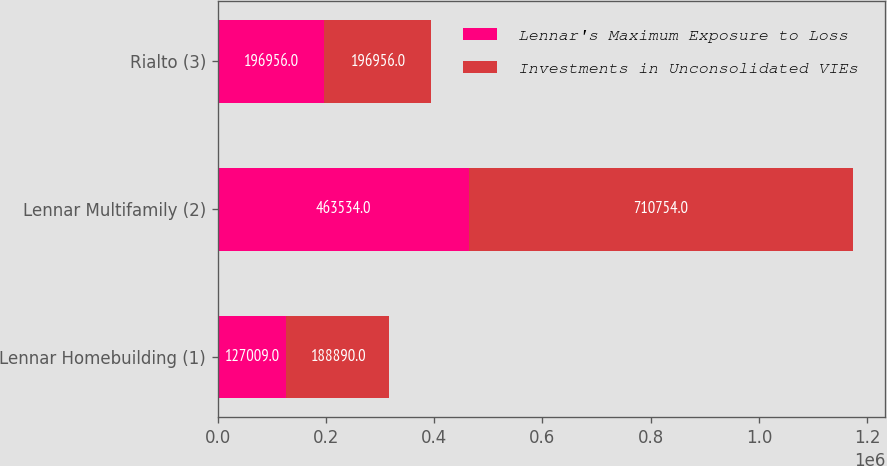Convert chart to OTSL. <chart><loc_0><loc_0><loc_500><loc_500><stacked_bar_chart><ecel><fcel>Lennar Homebuilding (1)<fcel>Lennar Multifamily (2)<fcel>Rialto (3)<nl><fcel>Lennar's Maximum Exposure to Loss<fcel>127009<fcel>463534<fcel>196956<nl><fcel>Investments in Unconsolidated VIEs<fcel>188890<fcel>710754<fcel>196956<nl></chart> 